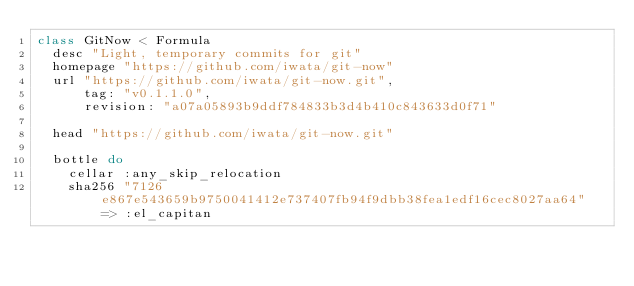Convert code to text. <code><loc_0><loc_0><loc_500><loc_500><_Ruby_>class GitNow < Formula
  desc "Light, temporary commits for git"
  homepage "https://github.com/iwata/git-now"
  url "https://github.com/iwata/git-now.git",
      tag: "v0.1.1.0",
      revision: "a07a05893b9ddf784833b3d4b410c843633d0f71"

  head "https://github.com/iwata/git-now.git"

  bottle do
    cellar :any_skip_relocation
    sha256 "7126e867e543659b9750041412e737407fb94f9dbb38fea1edf16cec8027aa64" => :el_capitan</code> 